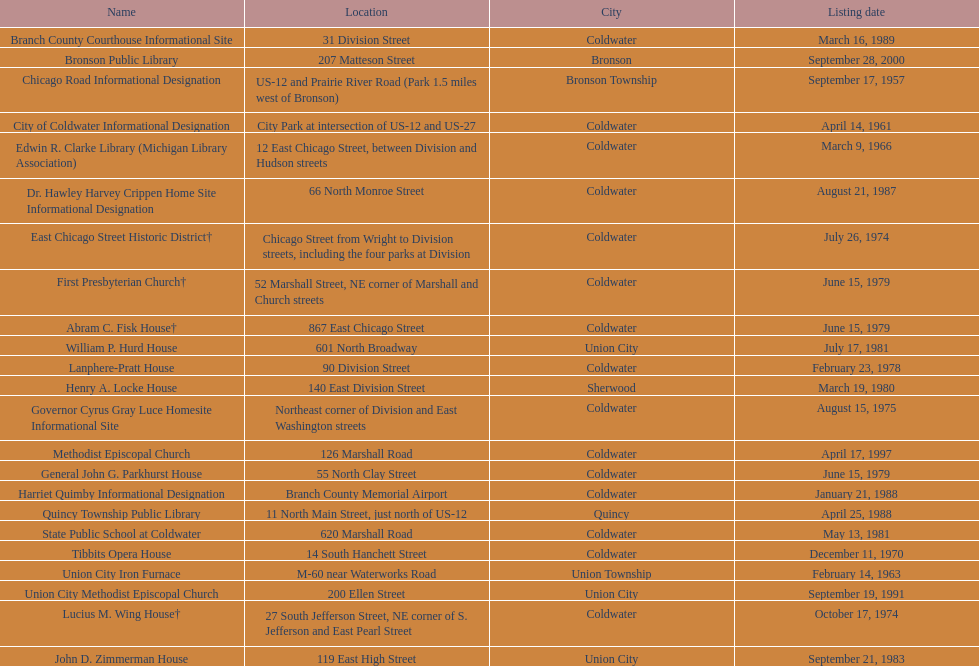What is the duration in years between the documented establishment of public libraries in quincy and bronson? 12. 